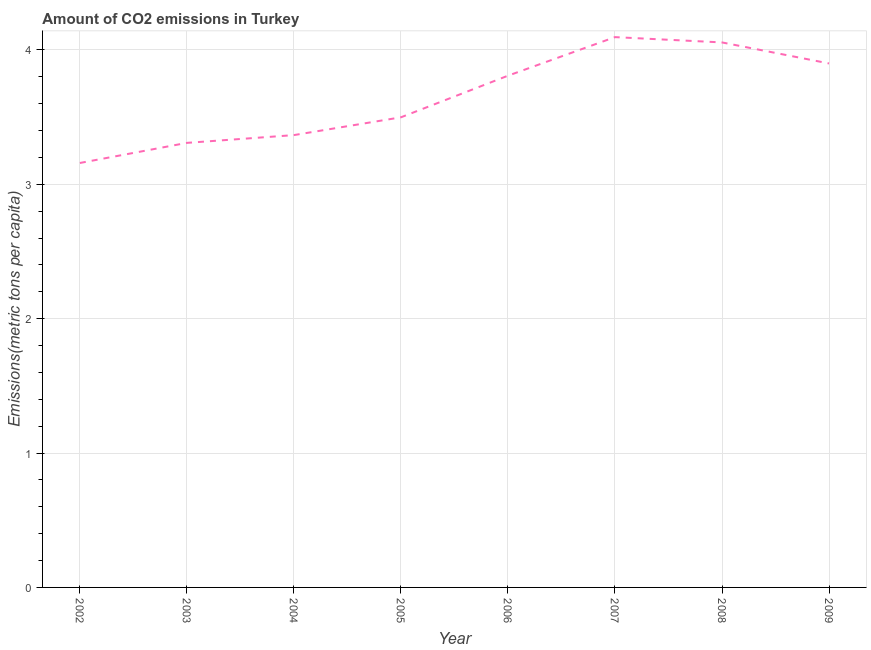What is the amount of co2 emissions in 2006?
Keep it short and to the point. 3.81. Across all years, what is the maximum amount of co2 emissions?
Ensure brevity in your answer.  4.09. Across all years, what is the minimum amount of co2 emissions?
Your answer should be compact. 3.16. In which year was the amount of co2 emissions maximum?
Your answer should be very brief. 2007. What is the sum of the amount of co2 emissions?
Make the answer very short. 29.19. What is the difference between the amount of co2 emissions in 2002 and 2008?
Keep it short and to the point. -0.9. What is the average amount of co2 emissions per year?
Offer a very short reply. 3.65. What is the median amount of co2 emissions?
Your answer should be very brief. 3.65. Do a majority of the years between 2004 and 2008 (inclusive) have amount of co2 emissions greater than 3.6 metric tons per capita?
Offer a terse response. Yes. What is the ratio of the amount of co2 emissions in 2002 to that in 2003?
Give a very brief answer. 0.95. Is the amount of co2 emissions in 2002 less than that in 2008?
Your response must be concise. Yes. Is the difference between the amount of co2 emissions in 2004 and 2008 greater than the difference between any two years?
Offer a terse response. No. What is the difference between the highest and the second highest amount of co2 emissions?
Make the answer very short. 0.04. Is the sum of the amount of co2 emissions in 2007 and 2008 greater than the maximum amount of co2 emissions across all years?
Make the answer very short. Yes. What is the difference between the highest and the lowest amount of co2 emissions?
Provide a short and direct response. 0.94. In how many years, is the amount of co2 emissions greater than the average amount of co2 emissions taken over all years?
Your answer should be compact. 4. How many years are there in the graph?
Offer a terse response. 8. Are the values on the major ticks of Y-axis written in scientific E-notation?
Your answer should be compact. No. What is the title of the graph?
Provide a short and direct response. Amount of CO2 emissions in Turkey. What is the label or title of the Y-axis?
Your response must be concise. Emissions(metric tons per capita). What is the Emissions(metric tons per capita) in 2002?
Keep it short and to the point. 3.16. What is the Emissions(metric tons per capita) in 2003?
Give a very brief answer. 3.31. What is the Emissions(metric tons per capita) of 2004?
Provide a succinct answer. 3.37. What is the Emissions(metric tons per capita) of 2005?
Offer a terse response. 3.5. What is the Emissions(metric tons per capita) in 2006?
Ensure brevity in your answer.  3.81. What is the Emissions(metric tons per capita) in 2007?
Provide a succinct answer. 4.09. What is the Emissions(metric tons per capita) of 2008?
Your answer should be very brief. 4.06. What is the Emissions(metric tons per capita) in 2009?
Offer a very short reply. 3.9. What is the difference between the Emissions(metric tons per capita) in 2002 and 2003?
Your response must be concise. -0.15. What is the difference between the Emissions(metric tons per capita) in 2002 and 2004?
Keep it short and to the point. -0.21. What is the difference between the Emissions(metric tons per capita) in 2002 and 2005?
Give a very brief answer. -0.34. What is the difference between the Emissions(metric tons per capita) in 2002 and 2006?
Your answer should be compact. -0.65. What is the difference between the Emissions(metric tons per capita) in 2002 and 2007?
Make the answer very short. -0.94. What is the difference between the Emissions(metric tons per capita) in 2002 and 2008?
Offer a very short reply. -0.9. What is the difference between the Emissions(metric tons per capita) in 2002 and 2009?
Give a very brief answer. -0.74. What is the difference between the Emissions(metric tons per capita) in 2003 and 2004?
Ensure brevity in your answer.  -0.06. What is the difference between the Emissions(metric tons per capita) in 2003 and 2005?
Offer a terse response. -0.19. What is the difference between the Emissions(metric tons per capita) in 2003 and 2006?
Give a very brief answer. -0.5. What is the difference between the Emissions(metric tons per capita) in 2003 and 2007?
Ensure brevity in your answer.  -0.79. What is the difference between the Emissions(metric tons per capita) in 2003 and 2008?
Keep it short and to the point. -0.75. What is the difference between the Emissions(metric tons per capita) in 2003 and 2009?
Offer a very short reply. -0.59. What is the difference between the Emissions(metric tons per capita) in 2004 and 2005?
Keep it short and to the point. -0.13. What is the difference between the Emissions(metric tons per capita) in 2004 and 2006?
Your response must be concise. -0.44. What is the difference between the Emissions(metric tons per capita) in 2004 and 2007?
Provide a short and direct response. -0.73. What is the difference between the Emissions(metric tons per capita) in 2004 and 2008?
Your answer should be compact. -0.69. What is the difference between the Emissions(metric tons per capita) in 2004 and 2009?
Keep it short and to the point. -0.53. What is the difference between the Emissions(metric tons per capita) in 2005 and 2006?
Offer a very short reply. -0.31. What is the difference between the Emissions(metric tons per capita) in 2005 and 2007?
Your answer should be very brief. -0.6. What is the difference between the Emissions(metric tons per capita) in 2005 and 2008?
Offer a very short reply. -0.56. What is the difference between the Emissions(metric tons per capita) in 2005 and 2009?
Your answer should be compact. -0.4. What is the difference between the Emissions(metric tons per capita) in 2006 and 2007?
Provide a succinct answer. -0.29. What is the difference between the Emissions(metric tons per capita) in 2006 and 2008?
Make the answer very short. -0.25. What is the difference between the Emissions(metric tons per capita) in 2006 and 2009?
Provide a succinct answer. -0.09. What is the difference between the Emissions(metric tons per capita) in 2007 and 2008?
Offer a terse response. 0.04. What is the difference between the Emissions(metric tons per capita) in 2007 and 2009?
Your answer should be very brief. 0.2. What is the difference between the Emissions(metric tons per capita) in 2008 and 2009?
Offer a terse response. 0.16. What is the ratio of the Emissions(metric tons per capita) in 2002 to that in 2003?
Provide a short and direct response. 0.95. What is the ratio of the Emissions(metric tons per capita) in 2002 to that in 2004?
Provide a succinct answer. 0.94. What is the ratio of the Emissions(metric tons per capita) in 2002 to that in 2005?
Provide a short and direct response. 0.9. What is the ratio of the Emissions(metric tons per capita) in 2002 to that in 2006?
Provide a succinct answer. 0.83. What is the ratio of the Emissions(metric tons per capita) in 2002 to that in 2007?
Provide a short and direct response. 0.77. What is the ratio of the Emissions(metric tons per capita) in 2002 to that in 2008?
Offer a very short reply. 0.78. What is the ratio of the Emissions(metric tons per capita) in 2002 to that in 2009?
Your response must be concise. 0.81. What is the ratio of the Emissions(metric tons per capita) in 2003 to that in 2004?
Your answer should be very brief. 0.98. What is the ratio of the Emissions(metric tons per capita) in 2003 to that in 2005?
Offer a terse response. 0.95. What is the ratio of the Emissions(metric tons per capita) in 2003 to that in 2006?
Offer a very short reply. 0.87. What is the ratio of the Emissions(metric tons per capita) in 2003 to that in 2007?
Offer a very short reply. 0.81. What is the ratio of the Emissions(metric tons per capita) in 2003 to that in 2008?
Offer a very short reply. 0.82. What is the ratio of the Emissions(metric tons per capita) in 2003 to that in 2009?
Your answer should be very brief. 0.85. What is the ratio of the Emissions(metric tons per capita) in 2004 to that in 2006?
Offer a terse response. 0.88. What is the ratio of the Emissions(metric tons per capita) in 2004 to that in 2007?
Your response must be concise. 0.82. What is the ratio of the Emissions(metric tons per capita) in 2004 to that in 2008?
Provide a succinct answer. 0.83. What is the ratio of the Emissions(metric tons per capita) in 2004 to that in 2009?
Make the answer very short. 0.86. What is the ratio of the Emissions(metric tons per capita) in 2005 to that in 2006?
Offer a very short reply. 0.92. What is the ratio of the Emissions(metric tons per capita) in 2005 to that in 2007?
Provide a succinct answer. 0.85. What is the ratio of the Emissions(metric tons per capita) in 2005 to that in 2008?
Ensure brevity in your answer.  0.86. What is the ratio of the Emissions(metric tons per capita) in 2005 to that in 2009?
Give a very brief answer. 0.9. What is the ratio of the Emissions(metric tons per capita) in 2006 to that in 2007?
Your response must be concise. 0.93. What is the ratio of the Emissions(metric tons per capita) in 2006 to that in 2008?
Give a very brief answer. 0.94. What is the ratio of the Emissions(metric tons per capita) in 2007 to that in 2008?
Keep it short and to the point. 1.01. What is the ratio of the Emissions(metric tons per capita) in 2008 to that in 2009?
Make the answer very short. 1.04. 